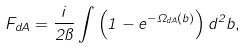<formula> <loc_0><loc_0><loc_500><loc_500>F _ { d A } = \frac { i } { 2 \pi } \int \left ( 1 - e ^ { - \Omega _ { d A } ( { b } ) } \right ) d ^ { 2 } { b } ,</formula> 